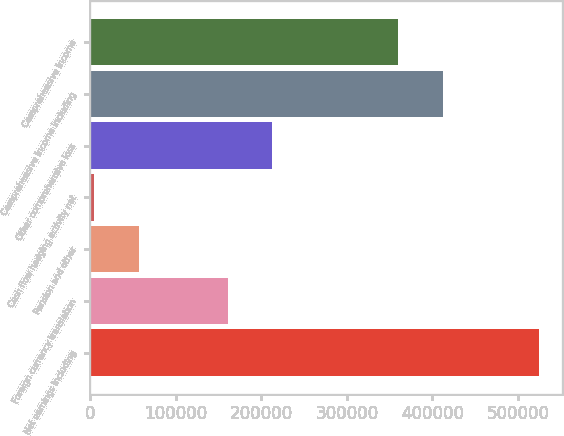<chart> <loc_0><loc_0><loc_500><loc_500><bar_chart><fcel>Net earnings including<fcel>Foreign currency translation<fcel>Pension and other<fcel>Cash flow hedging activity net<fcel>Other comprehensive loss<fcel>Comprehensive income including<fcel>Comprehensive income<nl><fcel>524885<fcel>160543<fcel>56444.9<fcel>4396<fcel>212592<fcel>411944<fcel>359895<nl></chart> 